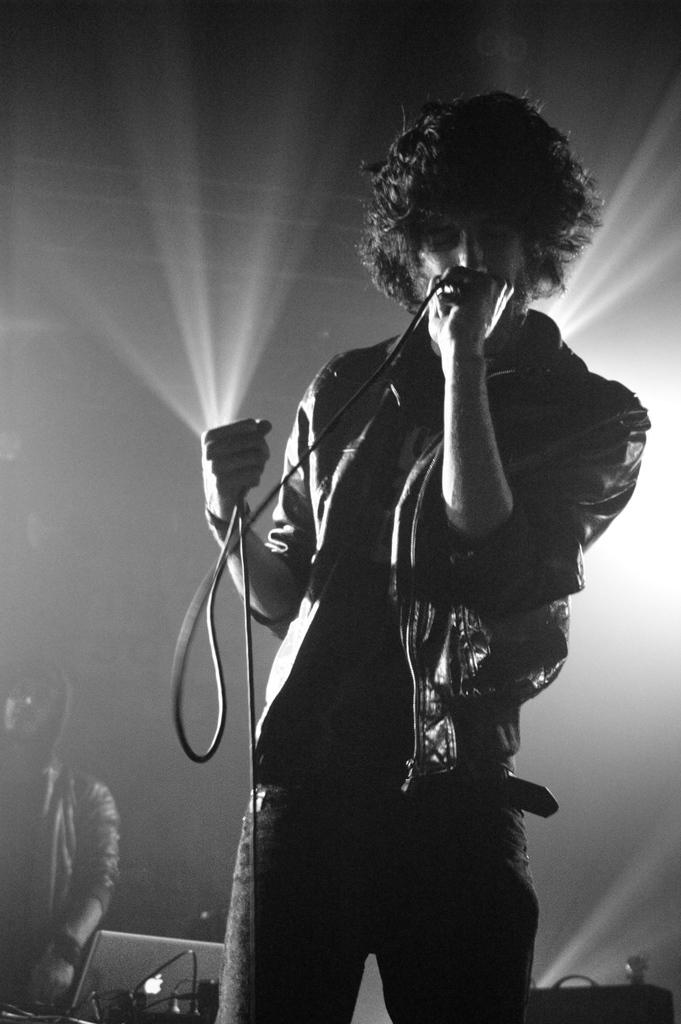What is the main subject of the image? There is a person in the image. What is the person doing in the image? The person is standing and singing a song. What object is the person holding in the image? The person is holding a microphone in the image. What type of lawyer is providing comfort to the person in the image? There is no lawyer present in the image, nor is anyone providing comfort to the person. The person is simply singing with a microphone. 